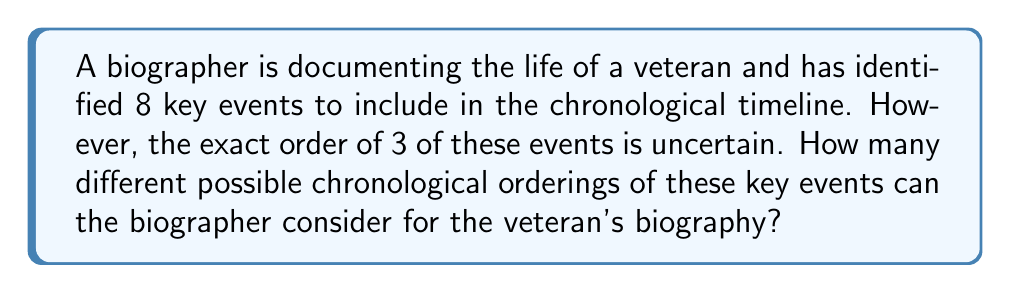Provide a solution to this math problem. Let's approach this step-by-step:

1) We have 8 total events, with 5 events having a known order and 3 events with an uncertain order.

2) The 5 events with a known order will remain fixed in their positions.

3) We need to determine in how many ways we can arrange the 3 uncertain events within the timeline.

4) This is a permutation problem. We are arranging 3 distinct events, and the order matters.

5) The formula for permutations of n distinct objects is:

   $$P(n) = n!$$

6) In this case, n = 3, so we calculate:

   $$P(3) = 3! = 3 \times 2 \times 1 = 6$$

7) Therefore, there are 6 possible ways to arrange the 3 uncertain events within the timeline.

8) Each of these 6 arrangements represents a unique chronological ordering of all 8 key events in the veteran's life.

Thus, the biographer has 6 different possible chronological orderings to consider for the veteran's biography.
Answer: 6 